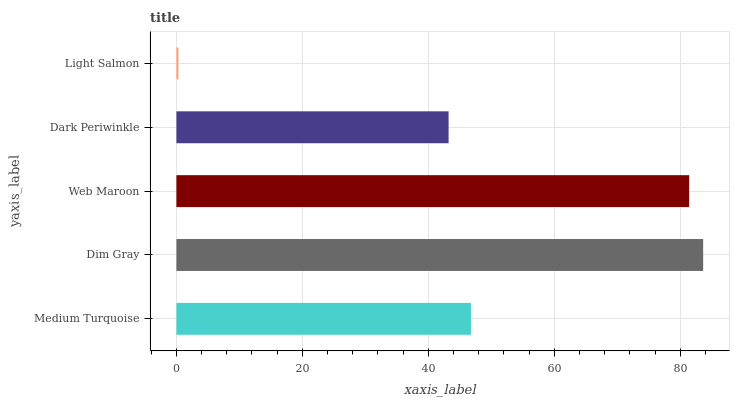Is Light Salmon the minimum?
Answer yes or no. Yes. Is Dim Gray the maximum?
Answer yes or no. Yes. Is Web Maroon the minimum?
Answer yes or no. No. Is Web Maroon the maximum?
Answer yes or no. No. Is Dim Gray greater than Web Maroon?
Answer yes or no. Yes. Is Web Maroon less than Dim Gray?
Answer yes or no. Yes. Is Web Maroon greater than Dim Gray?
Answer yes or no. No. Is Dim Gray less than Web Maroon?
Answer yes or no. No. Is Medium Turquoise the high median?
Answer yes or no. Yes. Is Medium Turquoise the low median?
Answer yes or no. Yes. Is Dim Gray the high median?
Answer yes or no. No. Is Web Maroon the low median?
Answer yes or no. No. 